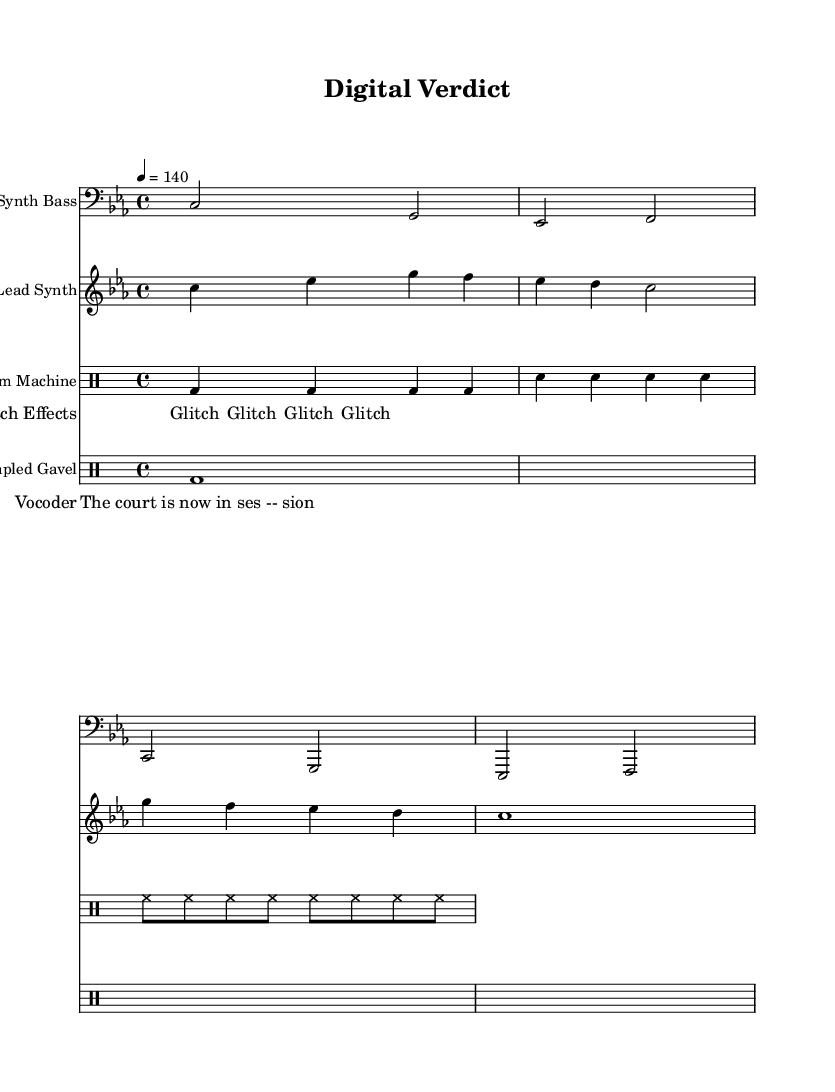What is the key signature of this music? The key signature indicates that the music is in C minor, which is shown by the three flats placed on the staff.
Answer: C minor What is the time signature of this music? The time signature is 4/4, which is displayed at the beginning of the score, indicating four beats per measure.
Answer: 4/4 What is the tempo marking for this piece? The tempo marking of "4 = 140" signifies that there are 140 beats per minute, which can be found in the global section of the code.
Answer: 140 How many times does the glitch effect repeat? The glitch effect is indicated to repeat "unfold 4," meaning it repeats four times as specified in the lyric mode section.
Answer: 4 times What type of instrument is represented by the "Lead Synth"? The "Lead Synth" is shown in the score by the specific staff designation and is categorized under "relative c''" pitch indications, identifying it as a synthesizer sound.
Answer: Synthesizer What is the purpose of the "Sampled Gavel" in this composition? The "Sampled Gavel" is included to represent courtroom sound effects, which serve to enhance the theme of the piece, being directly indicated as a separate DrumStaff in the score.
Answer: Courtroom sound effects What is the content of the vocoder lyrics? The vocoder lyrics state, "The court is now in ses -- sion," capturing a courtroom phrase relevant to the piece's theme and offered under the specific lyric mode section.
Answer: "The court is now in session." 